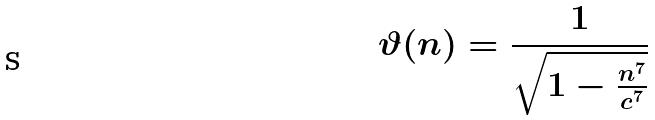Convert formula to latex. <formula><loc_0><loc_0><loc_500><loc_500>\vartheta ( n ) = \frac { 1 } { \sqrt { 1 - \frac { n ^ { 7 } } { c ^ { 7 } } } }</formula> 